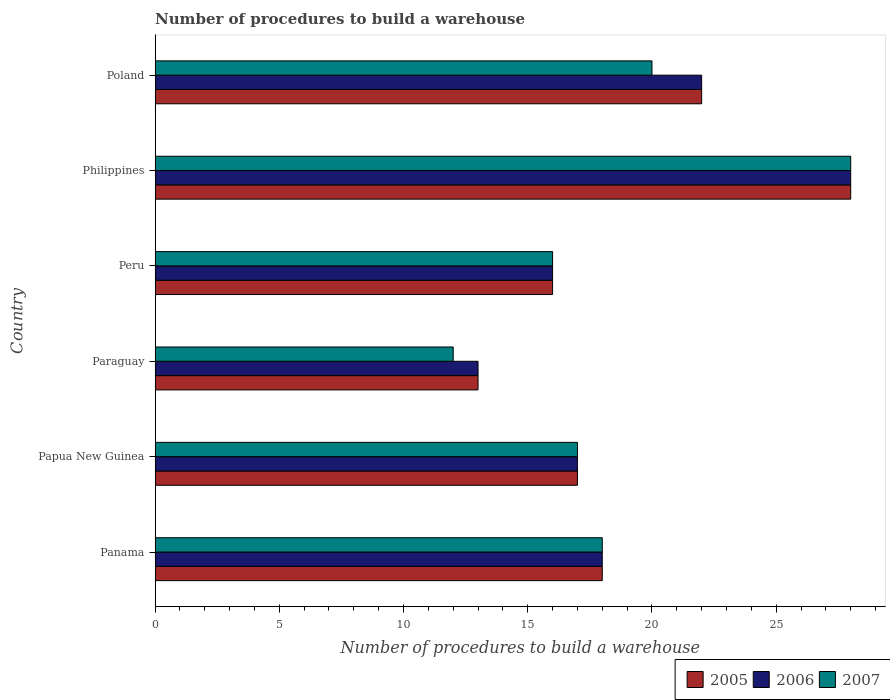How many groups of bars are there?
Your answer should be very brief. 6. How many bars are there on the 5th tick from the bottom?
Give a very brief answer. 3. What is the label of the 4th group of bars from the top?
Provide a succinct answer. Paraguay. In how many cases, is the number of bars for a given country not equal to the number of legend labels?
Give a very brief answer. 0. Across all countries, what is the maximum number of procedures to build a warehouse in in 2005?
Give a very brief answer. 28. In which country was the number of procedures to build a warehouse in in 2005 minimum?
Your answer should be compact. Paraguay. What is the total number of procedures to build a warehouse in in 2005 in the graph?
Ensure brevity in your answer.  114. What is the average number of procedures to build a warehouse in in 2007 per country?
Make the answer very short. 18.5. What is the difference between the number of procedures to build a warehouse in in 2006 and number of procedures to build a warehouse in in 2007 in Peru?
Make the answer very short. 0. What is the ratio of the number of procedures to build a warehouse in in 2005 in Paraguay to that in Poland?
Provide a succinct answer. 0.59. Is the number of procedures to build a warehouse in in 2006 in Paraguay less than that in Philippines?
Offer a very short reply. Yes. Is the difference between the number of procedures to build a warehouse in in 2006 in Panama and Peru greater than the difference between the number of procedures to build a warehouse in in 2007 in Panama and Peru?
Offer a very short reply. No. What is the difference between the highest and the second highest number of procedures to build a warehouse in in 2005?
Your answer should be very brief. 6. What is the difference between the highest and the lowest number of procedures to build a warehouse in in 2005?
Make the answer very short. 15. Is the sum of the number of procedures to build a warehouse in in 2006 in Panama and Paraguay greater than the maximum number of procedures to build a warehouse in in 2007 across all countries?
Make the answer very short. Yes. What does the 3rd bar from the top in Papua New Guinea represents?
Give a very brief answer. 2005. How many bars are there?
Your response must be concise. 18. How many countries are there in the graph?
Offer a very short reply. 6. Are the values on the major ticks of X-axis written in scientific E-notation?
Provide a short and direct response. No. Does the graph contain grids?
Your answer should be compact. No. Where does the legend appear in the graph?
Make the answer very short. Bottom right. How many legend labels are there?
Provide a succinct answer. 3. What is the title of the graph?
Give a very brief answer. Number of procedures to build a warehouse. What is the label or title of the X-axis?
Give a very brief answer. Number of procedures to build a warehouse. What is the Number of procedures to build a warehouse of 2005 in Panama?
Offer a very short reply. 18. What is the Number of procedures to build a warehouse in 2007 in Panama?
Your answer should be very brief. 18. What is the Number of procedures to build a warehouse of 2005 in Papua New Guinea?
Offer a very short reply. 17. What is the Number of procedures to build a warehouse of 2006 in Papua New Guinea?
Keep it short and to the point. 17. What is the Number of procedures to build a warehouse of 2007 in Papua New Guinea?
Provide a short and direct response. 17. What is the Number of procedures to build a warehouse of 2005 in Paraguay?
Ensure brevity in your answer.  13. What is the Number of procedures to build a warehouse in 2006 in Peru?
Offer a very short reply. 16. What is the Number of procedures to build a warehouse of 2005 in Philippines?
Provide a succinct answer. 28. What is the Number of procedures to build a warehouse of 2006 in Philippines?
Provide a succinct answer. 28. What is the Number of procedures to build a warehouse in 2007 in Philippines?
Your answer should be very brief. 28. What is the Number of procedures to build a warehouse of 2005 in Poland?
Provide a succinct answer. 22. What is the Number of procedures to build a warehouse in 2006 in Poland?
Provide a short and direct response. 22. What is the Number of procedures to build a warehouse of 2007 in Poland?
Your answer should be very brief. 20. Across all countries, what is the maximum Number of procedures to build a warehouse of 2007?
Give a very brief answer. 28. Across all countries, what is the minimum Number of procedures to build a warehouse of 2006?
Offer a very short reply. 13. Across all countries, what is the minimum Number of procedures to build a warehouse of 2007?
Make the answer very short. 12. What is the total Number of procedures to build a warehouse of 2005 in the graph?
Your response must be concise. 114. What is the total Number of procedures to build a warehouse of 2006 in the graph?
Offer a very short reply. 114. What is the total Number of procedures to build a warehouse of 2007 in the graph?
Give a very brief answer. 111. What is the difference between the Number of procedures to build a warehouse of 2005 in Panama and that in Papua New Guinea?
Make the answer very short. 1. What is the difference between the Number of procedures to build a warehouse in 2006 in Panama and that in Papua New Guinea?
Provide a short and direct response. 1. What is the difference between the Number of procedures to build a warehouse of 2007 in Panama and that in Papua New Guinea?
Make the answer very short. 1. What is the difference between the Number of procedures to build a warehouse of 2006 in Panama and that in Peru?
Your response must be concise. 2. What is the difference between the Number of procedures to build a warehouse of 2007 in Panama and that in Peru?
Give a very brief answer. 2. What is the difference between the Number of procedures to build a warehouse in 2005 in Panama and that in Philippines?
Provide a succinct answer. -10. What is the difference between the Number of procedures to build a warehouse of 2005 in Panama and that in Poland?
Give a very brief answer. -4. What is the difference between the Number of procedures to build a warehouse of 2006 in Panama and that in Poland?
Ensure brevity in your answer.  -4. What is the difference between the Number of procedures to build a warehouse of 2007 in Panama and that in Poland?
Offer a terse response. -2. What is the difference between the Number of procedures to build a warehouse in 2005 in Papua New Guinea and that in Paraguay?
Give a very brief answer. 4. What is the difference between the Number of procedures to build a warehouse in 2005 in Papua New Guinea and that in Peru?
Ensure brevity in your answer.  1. What is the difference between the Number of procedures to build a warehouse of 2006 in Papua New Guinea and that in Peru?
Give a very brief answer. 1. What is the difference between the Number of procedures to build a warehouse of 2007 in Papua New Guinea and that in Peru?
Keep it short and to the point. 1. What is the difference between the Number of procedures to build a warehouse in 2005 in Papua New Guinea and that in Philippines?
Your answer should be very brief. -11. What is the difference between the Number of procedures to build a warehouse in 2007 in Papua New Guinea and that in Philippines?
Provide a succinct answer. -11. What is the difference between the Number of procedures to build a warehouse of 2005 in Papua New Guinea and that in Poland?
Ensure brevity in your answer.  -5. What is the difference between the Number of procedures to build a warehouse in 2006 in Papua New Guinea and that in Poland?
Your response must be concise. -5. What is the difference between the Number of procedures to build a warehouse in 2006 in Paraguay and that in Peru?
Ensure brevity in your answer.  -3. What is the difference between the Number of procedures to build a warehouse of 2007 in Paraguay and that in Peru?
Provide a short and direct response. -4. What is the difference between the Number of procedures to build a warehouse in 2005 in Paraguay and that in Philippines?
Provide a succinct answer. -15. What is the difference between the Number of procedures to build a warehouse in 2005 in Paraguay and that in Poland?
Offer a terse response. -9. What is the difference between the Number of procedures to build a warehouse of 2006 in Paraguay and that in Poland?
Your answer should be compact. -9. What is the difference between the Number of procedures to build a warehouse of 2007 in Paraguay and that in Poland?
Offer a very short reply. -8. What is the difference between the Number of procedures to build a warehouse of 2007 in Philippines and that in Poland?
Your response must be concise. 8. What is the difference between the Number of procedures to build a warehouse of 2005 in Panama and the Number of procedures to build a warehouse of 2006 in Papua New Guinea?
Provide a succinct answer. 1. What is the difference between the Number of procedures to build a warehouse of 2005 in Panama and the Number of procedures to build a warehouse of 2007 in Papua New Guinea?
Provide a succinct answer. 1. What is the difference between the Number of procedures to build a warehouse of 2006 in Panama and the Number of procedures to build a warehouse of 2007 in Papua New Guinea?
Make the answer very short. 1. What is the difference between the Number of procedures to build a warehouse of 2005 in Panama and the Number of procedures to build a warehouse of 2006 in Paraguay?
Your answer should be compact. 5. What is the difference between the Number of procedures to build a warehouse of 2006 in Panama and the Number of procedures to build a warehouse of 2007 in Paraguay?
Provide a succinct answer. 6. What is the difference between the Number of procedures to build a warehouse in 2005 in Panama and the Number of procedures to build a warehouse in 2006 in Peru?
Provide a short and direct response. 2. What is the difference between the Number of procedures to build a warehouse of 2005 in Panama and the Number of procedures to build a warehouse of 2007 in Philippines?
Make the answer very short. -10. What is the difference between the Number of procedures to build a warehouse in 2006 in Panama and the Number of procedures to build a warehouse in 2007 in Philippines?
Offer a terse response. -10. What is the difference between the Number of procedures to build a warehouse of 2005 in Papua New Guinea and the Number of procedures to build a warehouse of 2007 in Paraguay?
Ensure brevity in your answer.  5. What is the difference between the Number of procedures to build a warehouse in 2005 in Papua New Guinea and the Number of procedures to build a warehouse in 2007 in Peru?
Provide a short and direct response. 1. What is the difference between the Number of procedures to build a warehouse of 2005 in Papua New Guinea and the Number of procedures to build a warehouse of 2006 in Philippines?
Provide a succinct answer. -11. What is the difference between the Number of procedures to build a warehouse of 2005 in Papua New Guinea and the Number of procedures to build a warehouse of 2007 in Philippines?
Offer a terse response. -11. What is the difference between the Number of procedures to build a warehouse of 2006 in Papua New Guinea and the Number of procedures to build a warehouse of 2007 in Poland?
Give a very brief answer. -3. What is the difference between the Number of procedures to build a warehouse in 2005 in Paraguay and the Number of procedures to build a warehouse in 2006 in Peru?
Provide a succinct answer. -3. What is the difference between the Number of procedures to build a warehouse in 2006 in Paraguay and the Number of procedures to build a warehouse in 2007 in Peru?
Give a very brief answer. -3. What is the difference between the Number of procedures to build a warehouse in 2005 in Paraguay and the Number of procedures to build a warehouse in 2006 in Philippines?
Your response must be concise. -15. What is the difference between the Number of procedures to build a warehouse of 2006 in Paraguay and the Number of procedures to build a warehouse of 2007 in Philippines?
Offer a very short reply. -15. What is the difference between the Number of procedures to build a warehouse of 2006 in Paraguay and the Number of procedures to build a warehouse of 2007 in Poland?
Offer a terse response. -7. What is the difference between the Number of procedures to build a warehouse of 2005 in Peru and the Number of procedures to build a warehouse of 2007 in Poland?
Give a very brief answer. -4. What is the average Number of procedures to build a warehouse in 2006 per country?
Your answer should be compact. 19. What is the average Number of procedures to build a warehouse of 2007 per country?
Your response must be concise. 18.5. What is the difference between the Number of procedures to build a warehouse in 2005 and Number of procedures to build a warehouse in 2007 in Panama?
Keep it short and to the point. 0. What is the difference between the Number of procedures to build a warehouse of 2005 and Number of procedures to build a warehouse of 2006 in Papua New Guinea?
Ensure brevity in your answer.  0. What is the difference between the Number of procedures to build a warehouse in 2005 and Number of procedures to build a warehouse in 2007 in Papua New Guinea?
Offer a very short reply. 0. What is the difference between the Number of procedures to build a warehouse in 2005 and Number of procedures to build a warehouse in 2006 in Paraguay?
Make the answer very short. 0. What is the difference between the Number of procedures to build a warehouse in 2006 and Number of procedures to build a warehouse in 2007 in Paraguay?
Give a very brief answer. 1. What is the difference between the Number of procedures to build a warehouse of 2005 and Number of procedures to build a warehouse of 2006 in Peru?
Your response must be concise. 0. What is the difference between the Number of procedures to build a warehouse in 2005 and Number of procedures to build a warehouse in 2006 in Philippines?
Your answer should be very brief. 0. What is the difference between the Number of procedures to build a warehouse of 2005 and Number of procedures to build a warehouse of 2007 in Philippines?
Offer a very short reply. 0. What is the difference between the Number of procedures to build a warehouse in 2005 and Number of procedures to build a warehouse in 2006 in Poland?
Offer a terse response. 0. What is the difference between the Number of procedures to build a warehouse of 2005 and Number of procedures to build a warehouse of 2007 in Poland?
Your answer should be compact. 2. What is the difference between the Number of procedures to build a warehouse in 2006 and Number of procedures to build a warehouse in 2007 in Poland?
Give a very brief answer. 2. What is the ratio of the Number of procedures to build a warehouse of 2005 in Panama to that in Papua New Guinea?
Give a very brief answer. 1.06. What is the ratio of the Number of procedures to build a warehouse of 2006 in Panama to that in Papua New Guinea?
Offer a terse response. 1.06. What is the ratio of the Number of procedures to build a warehouse in 2007 in Panama to that in Papua New Guinea?
Give a very brief answer. 1.06. What is the ratio of the Number of procedures to build a warehouse of 2005 in Panama to that in Paraguay?
Offer a terse response. 1.38. What is the ratio of the Number of procedures to build a warehouse of 2006 in Panama to that in Paraguay?
Provide a short and direct response. 1.38. What is the ratio of the Number of procedures to build a warehouse of 2005 in Panama to that in Peru?
Provide a short and direct response. 1.12. What is the ratio of the Number of procedures to build a warehouse in 2007 in Panama to that in Peru?
Your answer should be very brief. 1.12. What is the ratio of the Number of procedures to build a warehouse of 2005 in Panama to that in Philippines?
Provide a succinct answer. 0.64. What is the ratio of the Number of procedures to build a warehouse of 2006 in Panama to that in Philippines?
Your answer should be compact. 0.64. What is the ratio of the Number of procedures to build a warehouse of 2007 in Panama to that in Philippines?
Keep it short and to the point. 0.64. What is the ratio of the Number of procedures to build a warehouse in 2005 in Panama to that in Poland?
Your answer should be very brief. 0.82. What is the ratio of the Number of procedures to build a warehouse in 2006 in Panama to that in Poland?
Provide a short and direct response. 0.82. What is the ratio of the Number of procedures to build a warehouse in 2007 in Panama to that in Poland?
Give a very brief answer. 0.9. What is the ratio of the Number of procedures to build a warehouse in 2005 in Papua New Guinea to that in Paraguay?
Give a very brief answer. 1.31. What is the ratio of the Number of procedures to build a warehouse of 2006 in Papua New Guinea to that in Paraguay?
Keep it short and to the point. 1.31. What is the ratio of the Number of procedures to build a warehouse in 2007 in Papua New Guinea to that in Paraguay?
Ensure brevity in your answer.  1.42. What is the ratio of the Number of procedures to build a warehouse in 2007 in Papua New Guinea to that in Peru?
Your response must be concise. 1.06. What is the ratio of the Number of procedures to build a warehouse of 2005 in Papua New Guinea to that in Philippines?
Keep it short and to the point. 0.61. What is the ratio of the Number of procedures to build a warehouse in 2006 in Papua New Guinea to that in Philippines?
Make the answer very short. 0.61. What is the ratio of the Number of procedures to build a warehouse of 2007 in Papua New Guinea to that in Philippines?
Keep it short and to the point. 0.61. What is the ratio of the Number of procedures to build a warehouse of 2005 in Papua New Guinea to that in Poland?
Your response must be concise. 0.77. What is the ratio of the Number of procedures to build a warehouse of 2006 in Papua New Guinea to that in Poland?
Your answer should be compact. 0.77. What is the ratio of the Number of procedures to build a warehouse in 2005 in Paraguay to that in Peru?
Provide a short and direct response. 0.81. What is the ratio of the Number of procedures to build a warehouse of 2006 in Paraguay to that in Peru?
Ensure brevity in your answer.  0.81. What is the ratio of the Number of procedures to build a warehouse of 2007 in Paraguay to that in Peru?
Provide a succinct answer. 0.75. What is the ratio of the Number of procedures to build a warehouse in 2005 in Paraguay to that in Philippines?
Ensure brevity in your answer.  0.46. What is the ratio of the Number of procedures to build a warehouse of 2006 in Paraguay to that in Philippines?
Provide a succinct answer. 0.46. What is the ratio of the Number of procedures to build a warehouse of 2007 in Paraguay to that in Philippines?
Provide a succinct answer. 0.43. What is the ratio of the Number of procedures to build a warehouse in 2005 in Paraguay to that in Poland?
Ensure brevity in your answer.  0.59. What is the ratio of the Number of procedures to build a warehouse in 2006 in Paraguay to that in Poland?
Ensure brevity in your answer.  0.59. What is the ratio of the Number of procedures to build a warehouse of 2005 in Peru to that in Philippines?
Your response must be concise. 0.57. What is the ratio of the Number of procedures to build a warehouse in 2005 in Peru to that in Poland?
Your answer should be very brief. 0.73. What is the ratio of the Number of procedures to build a warehouse in 2006 in Peru to that in Poland?
Ensure brevity in your answer.  0.73. What is the ratio of the Number of procedures to build a warehouse of 2007 in Peru to that in Poland?
Keep it short and to the point. 0.8. What is the ratio of the Number of procedures to build a warehouse of 2005 in Philippines to that in Poland?
Your answer should be very brief. 1.27. What is the ratio of the Number of procedures to build a warehouse of 2006 in Philippines to that in Poland?
Keep it short and to the point. 1.27. What is the ratio of the Number of procedures to build a warehouse of 2007 in Philippines to that in Poland?
Provide a short and direct response. 1.4. 